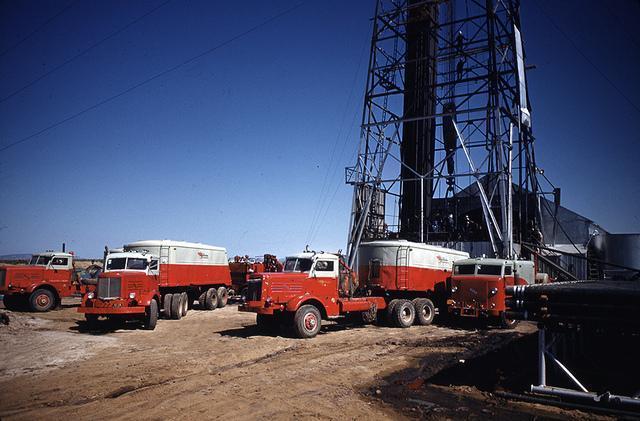How many red and white trucks are there?
Give a very brief answer. 4. How many trucks are in the photo?
Give a very brief answer. 4. How many people are in front of the engine?
Give a very brief answer. 0. 